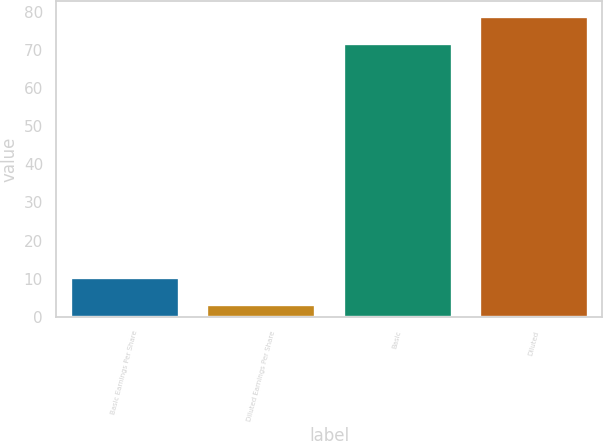<chart> <loc_0><loc_0><loc_500><loc_500><bar_chart><fcel>Basic Earnings Per Share<fcel>Diluted Earnings Per Share<fcel>Basic<fcel>Diluted<nl><fcel>10.34<fcel>3.33<fcel>71.76<fcel>78.77<nl></chart> 